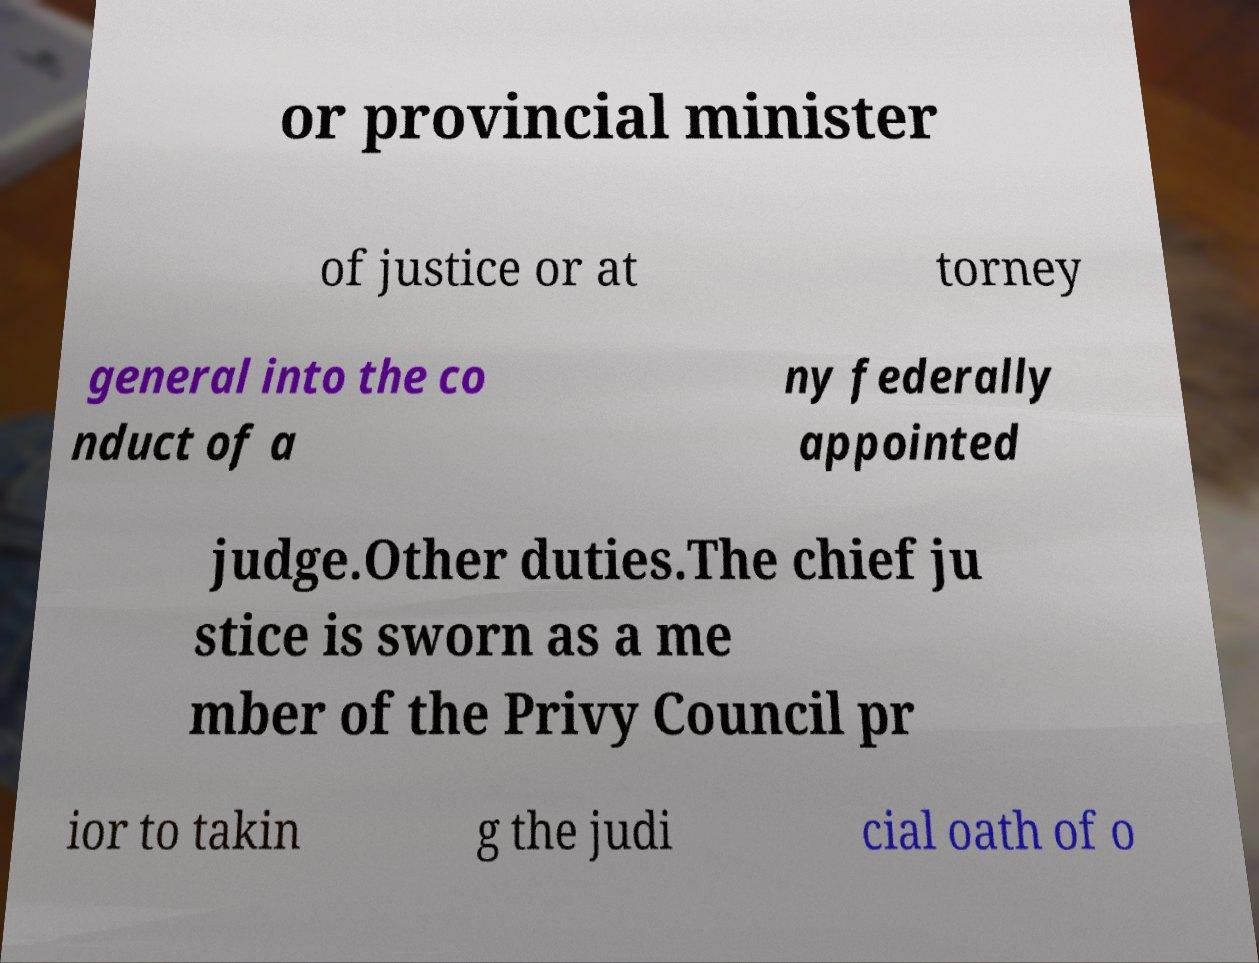What messages or text are displayed in this image? I need them in a readable, typed format. or provincial minister of justice or at torney general into the co nduct of a ny federally appointed judge.Other duties.The chief ju stice is sworn as a me mber of the Privy Council pr ior to takin g the judi cial oath of o 